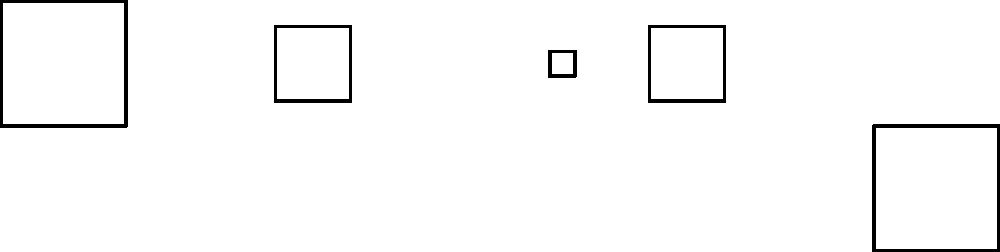In the sequence of Croatian Glagolitic script characters shown above, which character would logically come next? To solve this spatial reasoning task, let's analyze the pattern in the given sequence of Croatian Glagolitic script characters:

1. The first character is a large square.
2. The second character is a medium-sized square.
3. The third character is a small square.
4. The fourth character is the medium-sized square rotated 90 degrees clockwise.
5. The fifth character is the large square rotated 180 degrees.

Following this pattern, we can deduce that:

6. The next character should be the small square rotated 270 degrees clockwise (or 90 degrees counterclockwise).

This pattern showcases a fascinating aspect of the Glagolitic script, which is part of Croatia's rich cultural heritage. The spatial transformation of these characters demonstrates the script's geometric nature and its potential for creative representation in tourism promotions.
Answer: Small square rotated 270° 